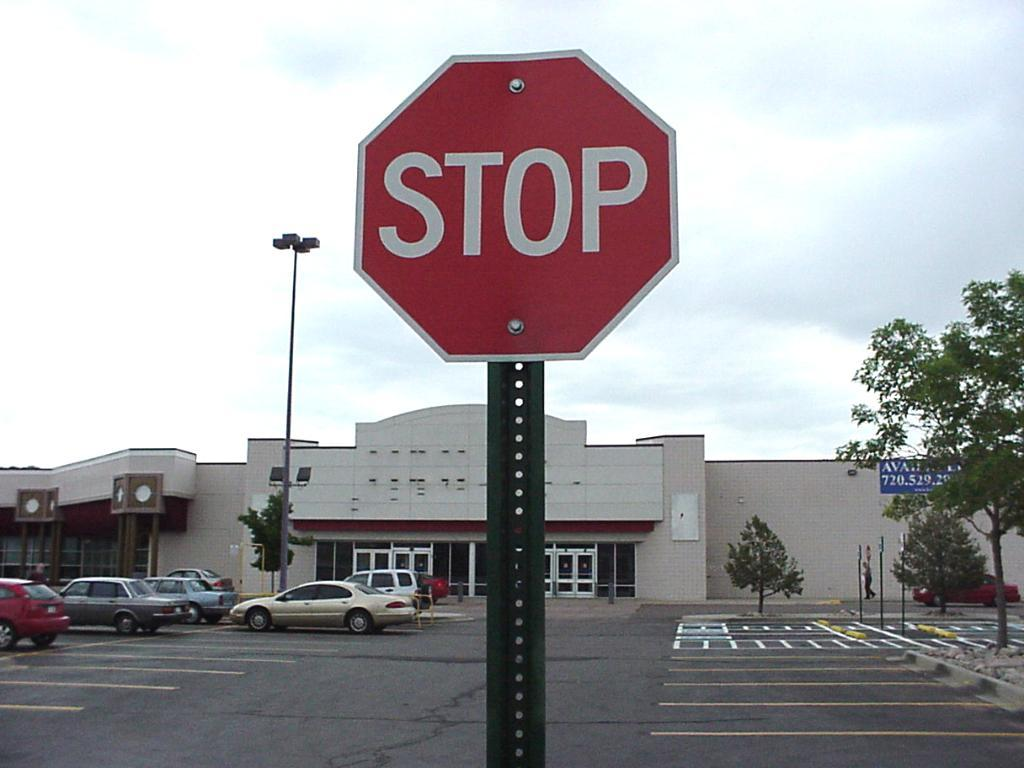Provide a one-sentence caption for the provided image. a stop sign that is outside in the day. 